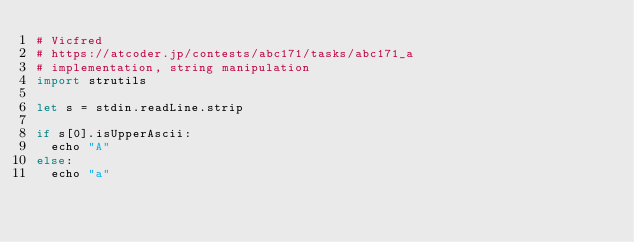<code> <loc_0><loc_0><loc_500><loc_500><_Nim_># Vicfred
# https://atcoder.jp/contests/abc171/tasks/abc171_a
# implementation, string manipulation
import strutils

let s = stdin.readLine.strip

if s[0].isUpperAscii:
  echo "A"
else:
  echo "a"

</code> 